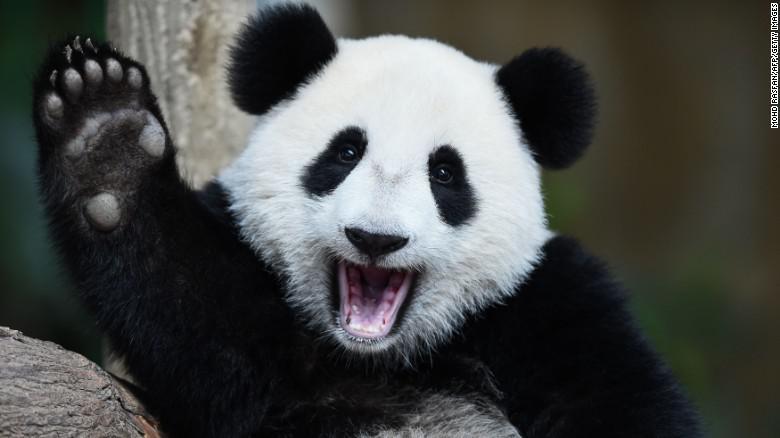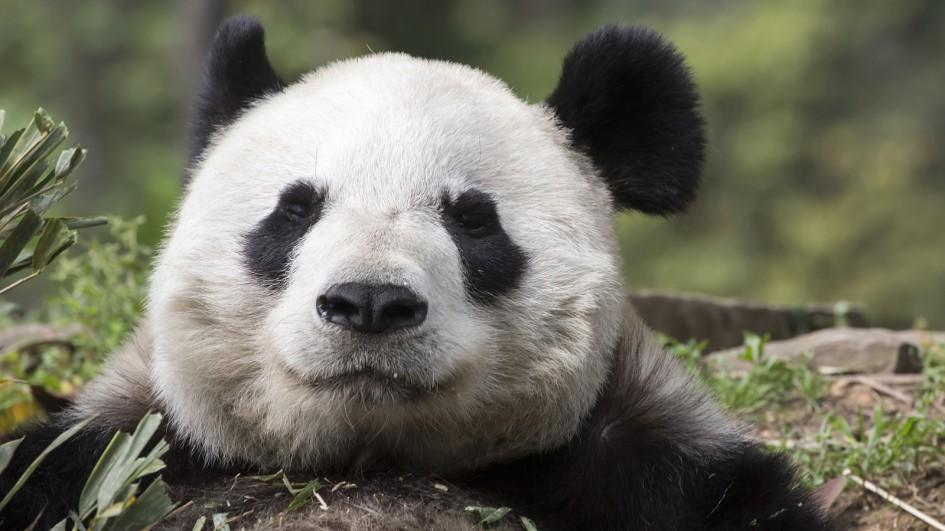The first image is the image on the left, the second image is the image on the right. Considering the images on both sides, is "An image shows exactly one panda, and it has an opened mouth." valid? Answer yes or no. Yes. The first image is the image on the left, the second image is the image on the right. Evaluate the accuracy of this statement regarding the images: "A single panda is in one image with its mouth open, showing the pink interior and some teeth.". Is it true? Answer yes or no. Yes. 